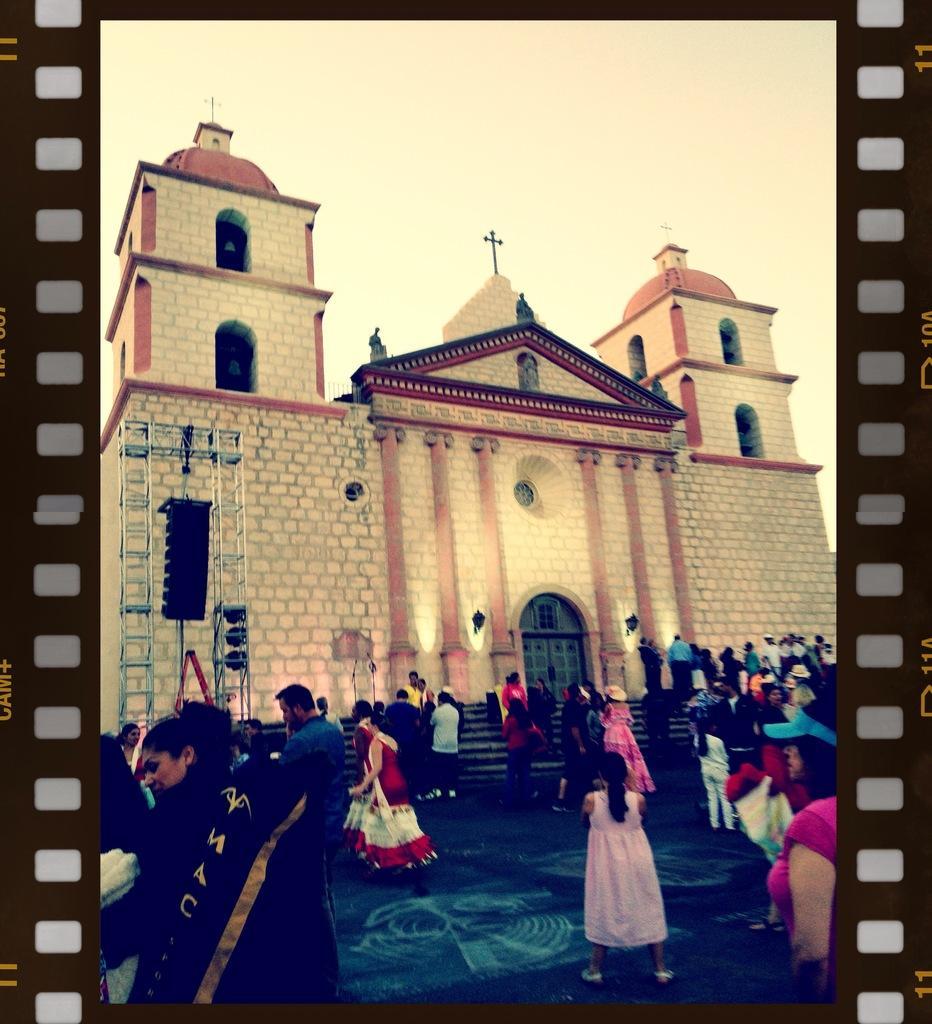Describe this image in one or two sentences. In this picture we can see a building with windows, doors, steps and a group of people standing on the ground. 